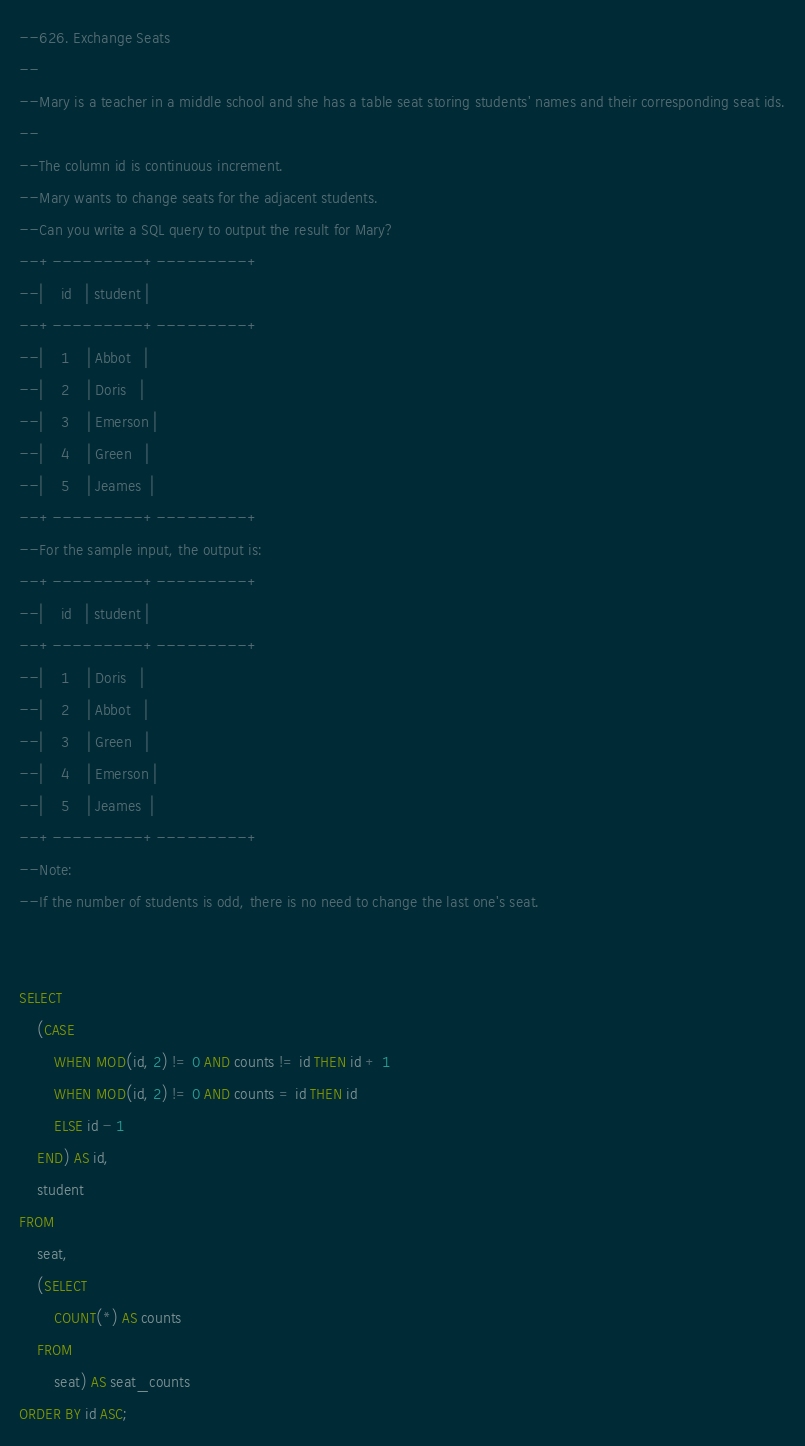Convert code to text. <code><loc_0><loc_0><loc_500><loc_500><_SQL_>--626. Exchange Seats
--
--Mary is a teacher in a middle school and she has a table seat storing students' names and their corresponding seat ids.
--
--The column id is continuous increment.
--Mary wants to change seats for the adjacent students.
--Can you write a SQL query to output the result for Mary?
--+---------+---------+
--|    id   | student |
--+---------+---------+
--|    1    | Abbot   |
--|    2    | Doris   |
--|    3    | Emerson |
--|    4    | Green   |
--|    5    | Jeames  |
--+---------+---------+
--For the sample input, the output is:
--+---------+---------+
--|    id   | student |
--+---------+---------+
--|    1    | Doris   |
--|    2    | Abbot   |
--|    3    | Green   |
--|    4    | Emerson |
--|    5    | Jeames  |
--+---------+---------+
--Note:
--If the number of students is odd, there is no need to change the last one's seat.


SELECT
    (CASE
        WHEN MOD(id, 2) != 0 AND counts != id THEN id + 1
        WHEN MOD(id, 2) != 0 AND counts = id THEN id
        ELSE id - 1
    END) AS id,
    student
FROM
    seat,
    (SELECT
        COUNT(*) AS counts
    FROM
        seat) AS seat_counts
ORDER BY id ASC;</code> 